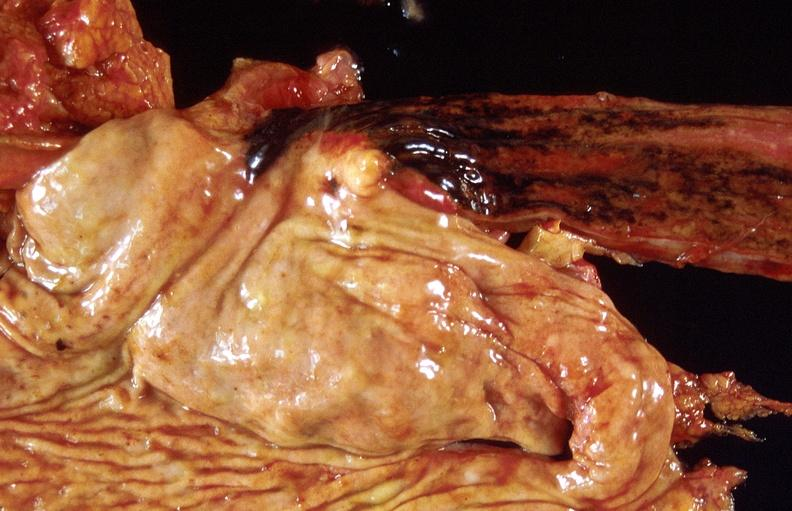does supernumerary digit show stress ulcers, stomach?
Answer the question using a single word or phrase. No 